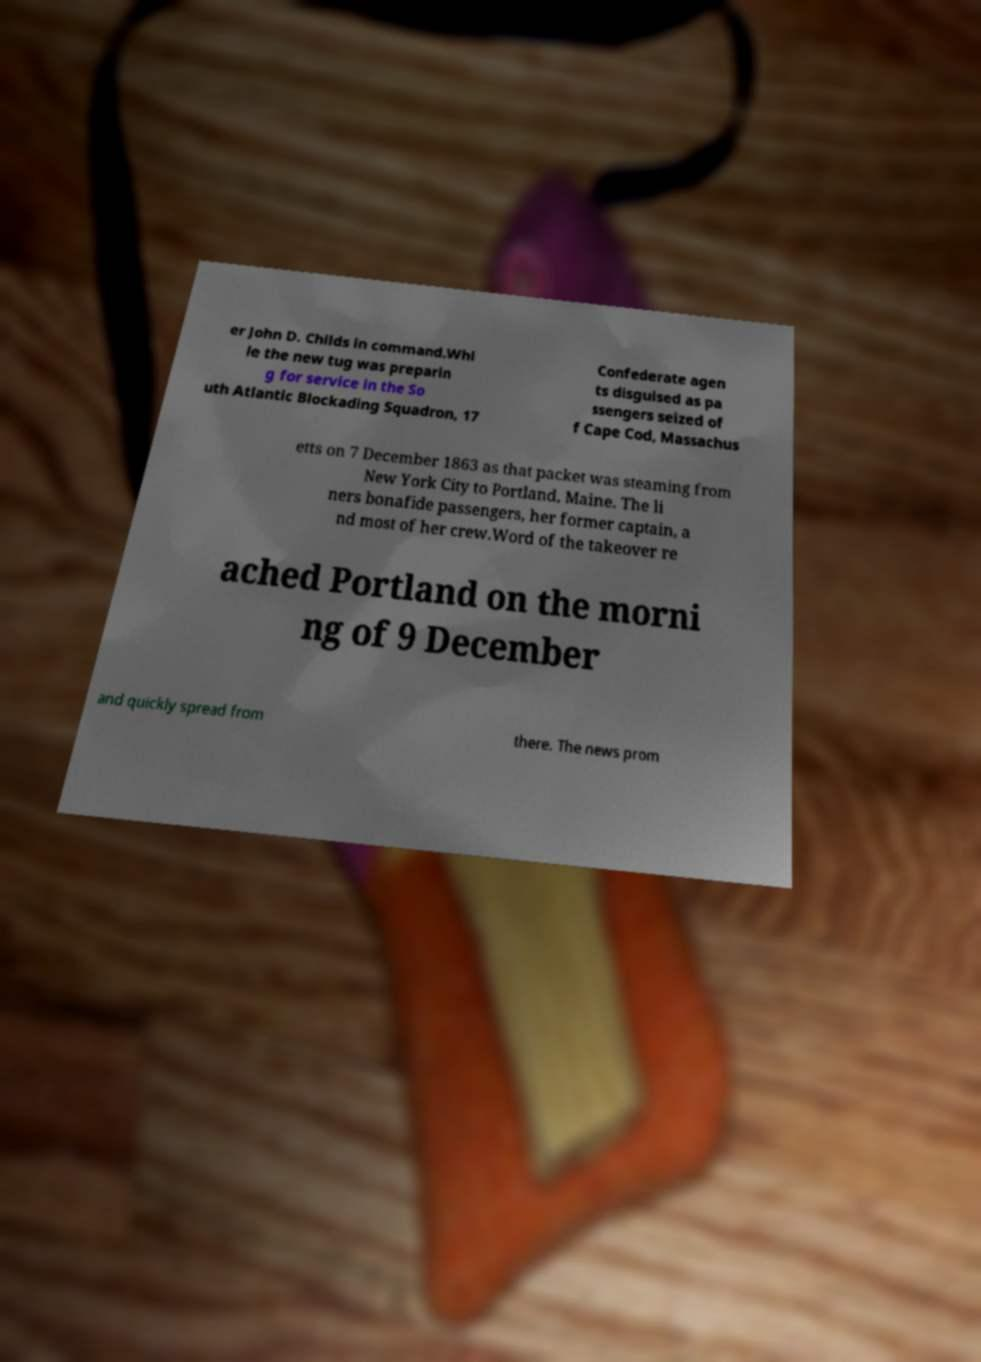There's text embedded in this image that I need extracted. Can you transcribe it verbatim? er John D. Childs in command.Whi le the new tug was preparin g for service in the So uth Atlantic Blockading Squadron, 17 Confederate agen ts disguised as pa ssengers seized of f Cape Cod, Massachus etts on 7 December 1863 as that packet was steaming from New York City to Portland, Maine. The li ners bonafide passengers, her former captain, a nd most of her crew.Word of the takeover re ached Portland on the morni ng of 9 December and quickly spread from there. The news prom 